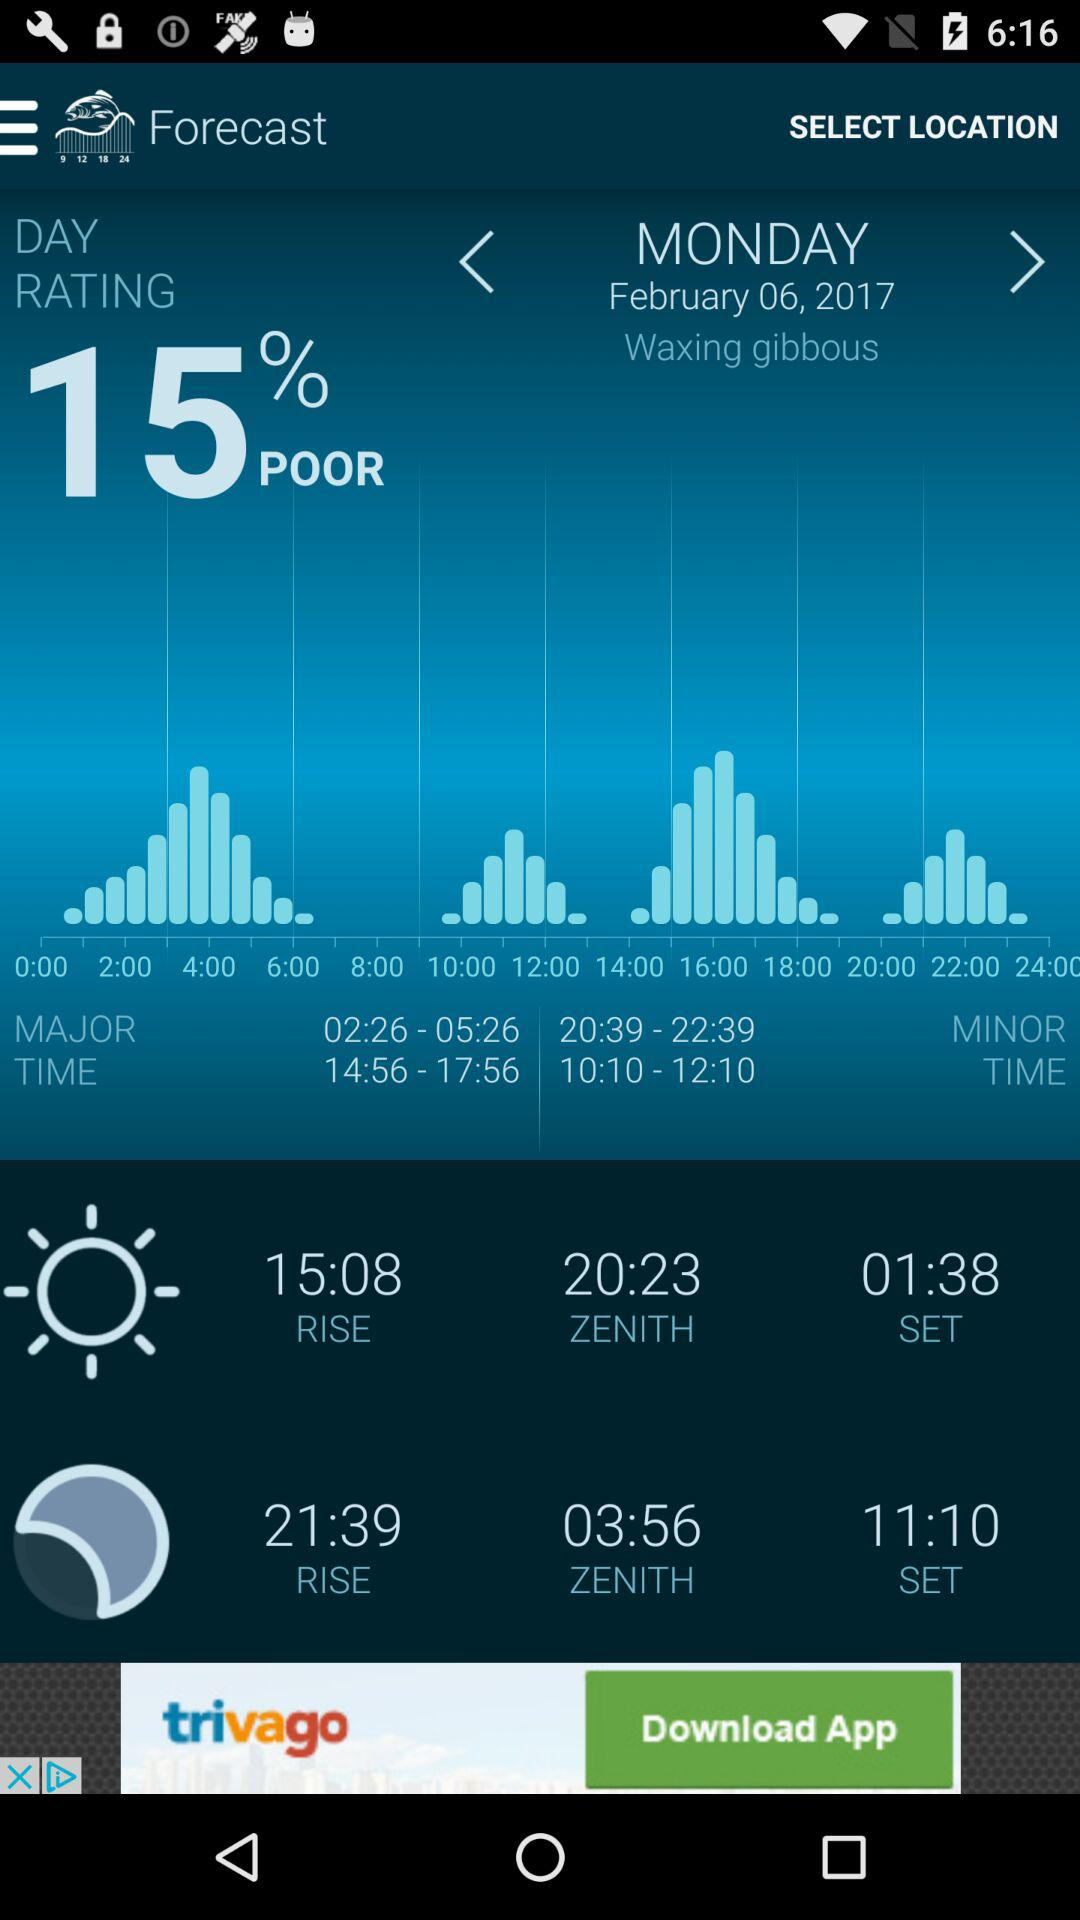What is the major timing? The major timing is from 02:26 to 05:26. 